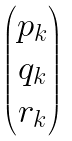<formula> <loc_0><loc_0><loc_500><loc_500>\begin{pmatrix} p _ { k } \\ q _ { k } \\ r _ { k } \end{pmatrix}</formula> 